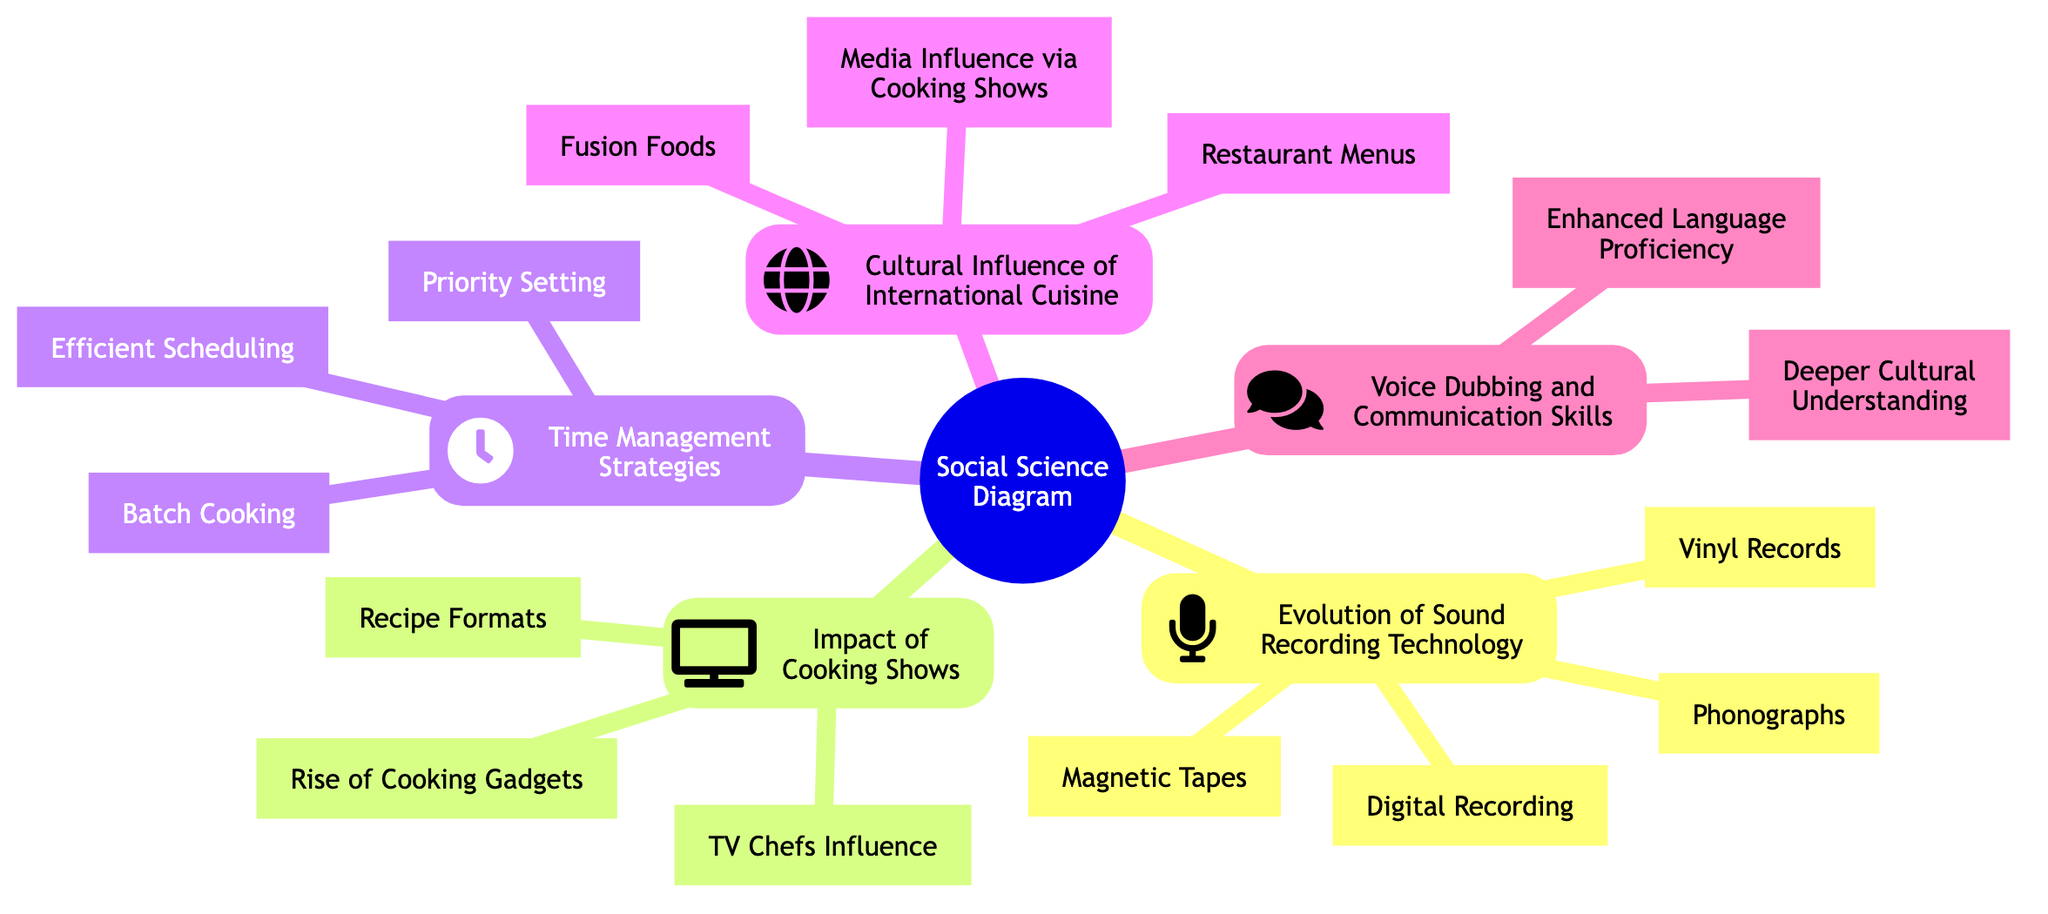What are the four main categories depicted in the diagram? The diagram includes five main categories: Evolution of Sound Recording Technology, Impact of Cooking Shows, Time Management Strategies, Cultural Influence of International Cuisine, and Voice Dubbing and Communication Skills.
Answer: Evolution of Sound Recording Technology, Impact of Cooking Shows, Time Management Strategies, Cultural Influence of International Cuisine, Voice Dubbing and Communication Skills How many advancements are listed under the Evolution of Sound Recording Technology? Under that category, there are four advancements mentioned: Phonographs, Vinyl Records, Magnetic Tapes, and Digital Recording.
Answer: Four What is one factor mentioned that symbolizes the Impact of Cooking Shows? The diagram highlights TV Chefs Influence as one of the factors related to cooking shows' impact on culinary practices.
Answer: TV Chefs Influence Which strategy listed is associated with managing creative work and personal hobbies? The strategy named Efficient Scheduling corresponds with balancing creative work and personal hobbies, as illustrated in the diagram.
Answer: Efficient Scheduling What two aspects are highlighted under the relationship between Voice Dubbing and Communication Skills? The two aspects mentioned are Enhanced Language Proficiency and Deeper Cultural Understanding, indicating the skills related to voice dubbing.
Answer: Enhanced Language Proficiency, Deeper Cultural Understanding How does the diagram relate TV Cooking Shows to modern households? The relationship is made through Media Influence via Cooking Shows, which suggests a connection between cooking shows and household culinary trends.
Answer: Media Influence via Cooking Shows What node indicates the growth of kitchen gadgets in households? The Rise of Cooking Gadgets node illustrates the trend of increased use of kitchen gadgets due to influences from TV cooking shows.
Answer: Rise of Cooking Gadgets What is the interrelation between International Cuisine and Fusion Foods depicted in the diagram? The diagram conveys that Fusion Foods arise from the Cultural Influence of International Cuisine, showing how cultures adapt and integrate foreign foods.
Answer: Fusion Foods What specific time management technique could help balance personal interests for a dubbing artist? Batch Cooking is a time management technique that could assist a dubbing artist in efficiently balancing their projects with kitchen experimentation.
Answer: Batch Cooking 